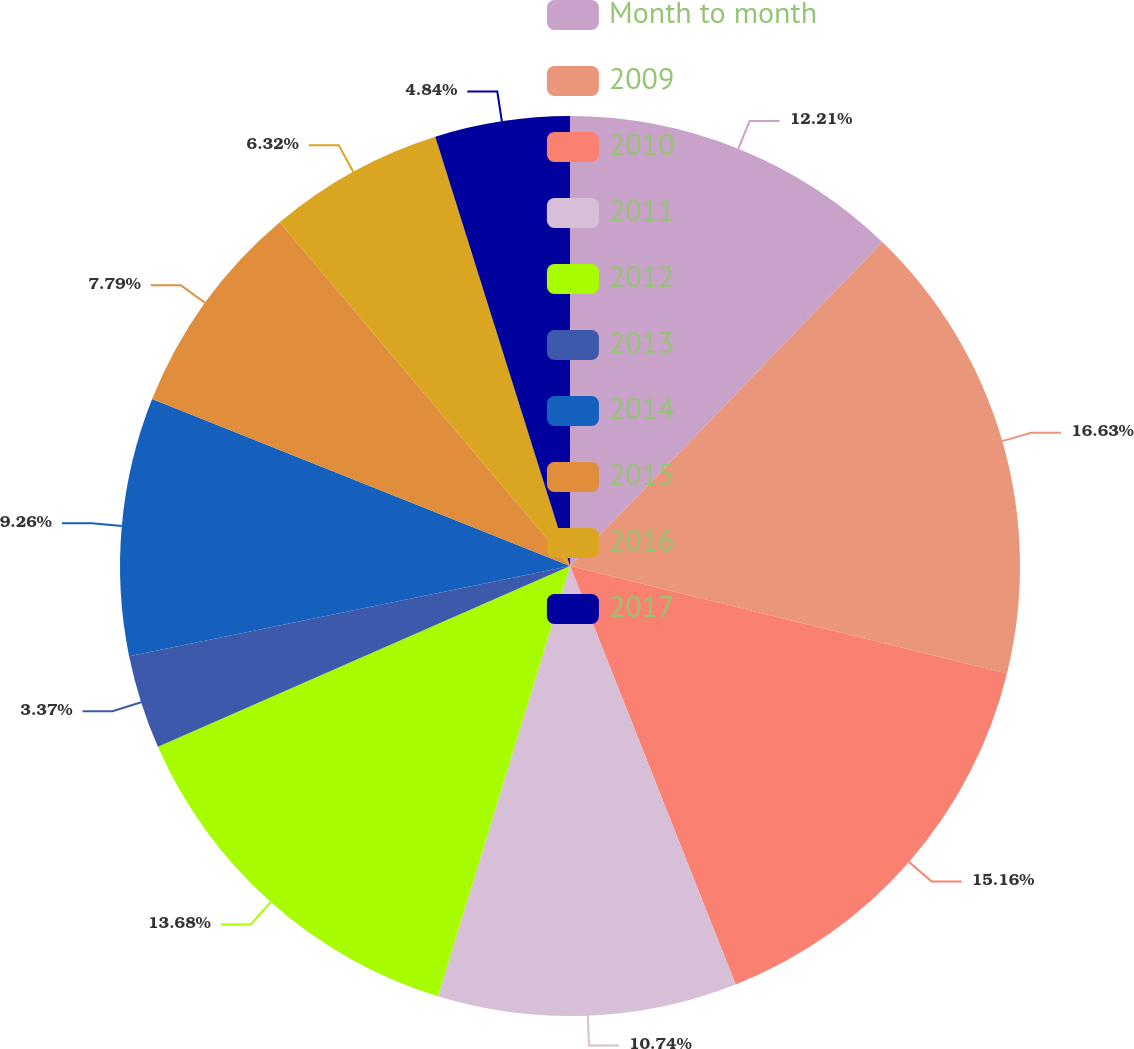Convert chart to OTSL. <chart><loc_0><loc_0><loc_500><loc_500><pie_chart><fcel>Month to month<fcel>2009<fcel>2010<fcel>2011<fcel>2012<fcel>2013<fcel>2014<fcel>2015<fcel>2016<fcel>2017<nl><fcel>12.21%<fcel>16.63%<fcel>15.16%<fcel>10.74%<fcel>13.68%<fcel>3.37%<fcel>9.26%<fcel>7.79%<fcel>6.32%<fcel>4.84%<nl></chart> 